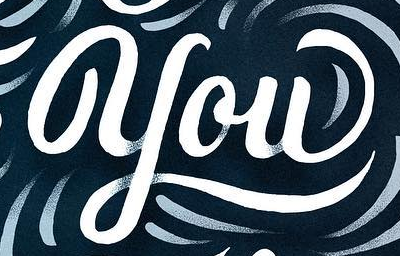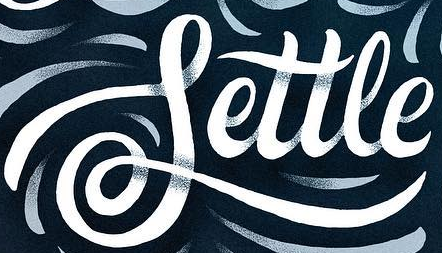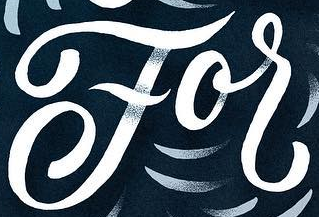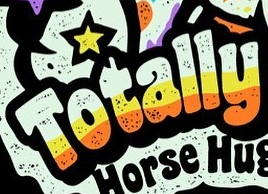What words can you see in these images in sequence, separated by a semicolon? you; Settle; For; Totally 